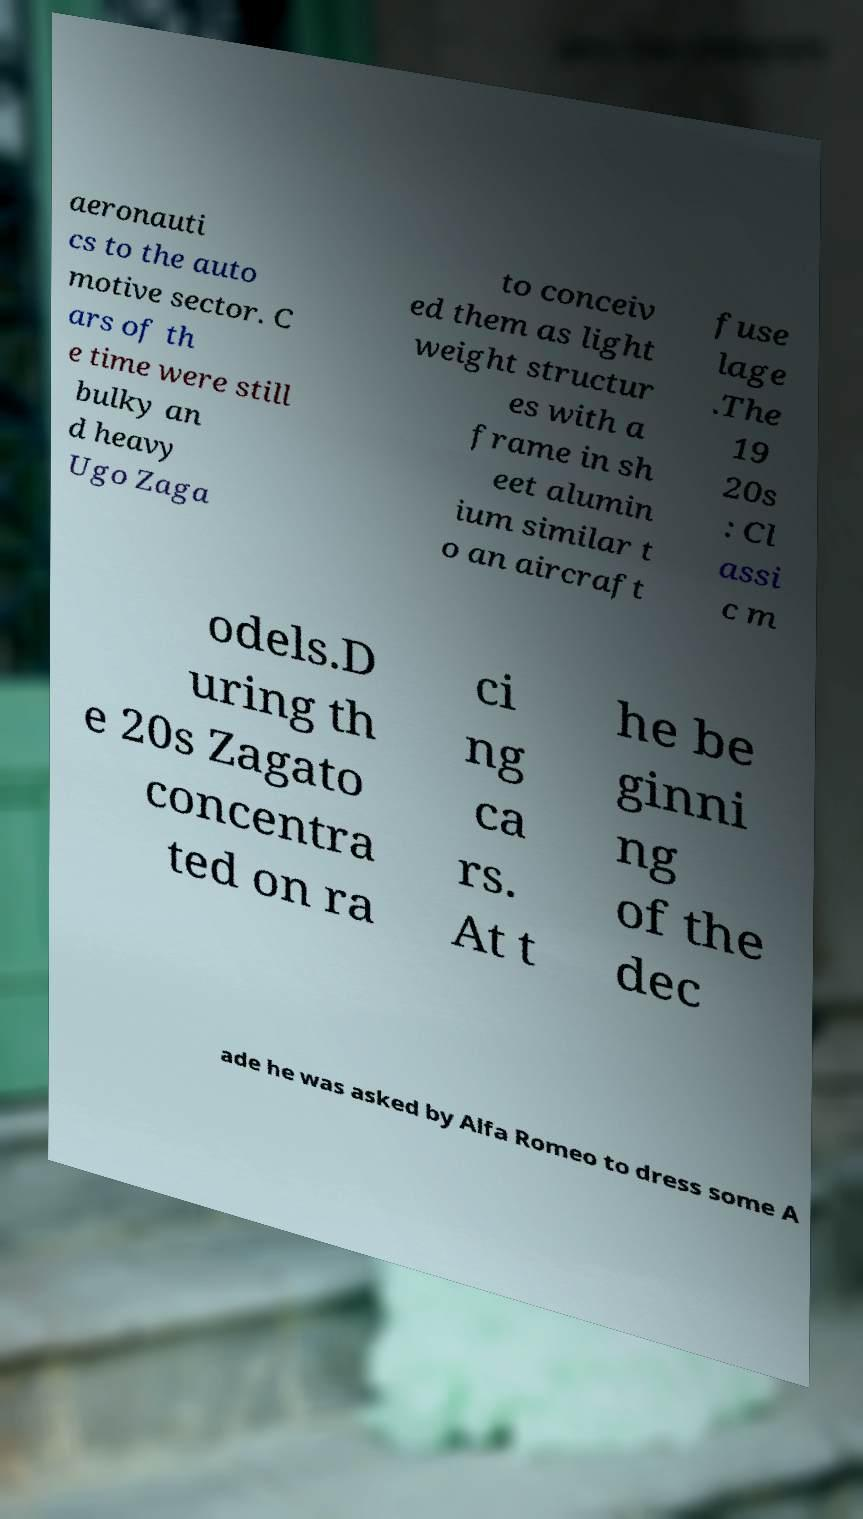Could you extract and type out the text from this image? aeronauti cs to the auto motive sector. C ars of th e time were still bulky an d heavy Ugo Zaga to conceiv ed them as light weight structur es with a frame in sh eet alumin ium similar t o an aircraft fuse lage .The 19 20s : Cl assi c m odels.D uring th e 20s Zagato concentra ted on ra ci ng ca rs. At t he be ginni ng of the dec ade he was asked by Alfa Romeo to dress some A 